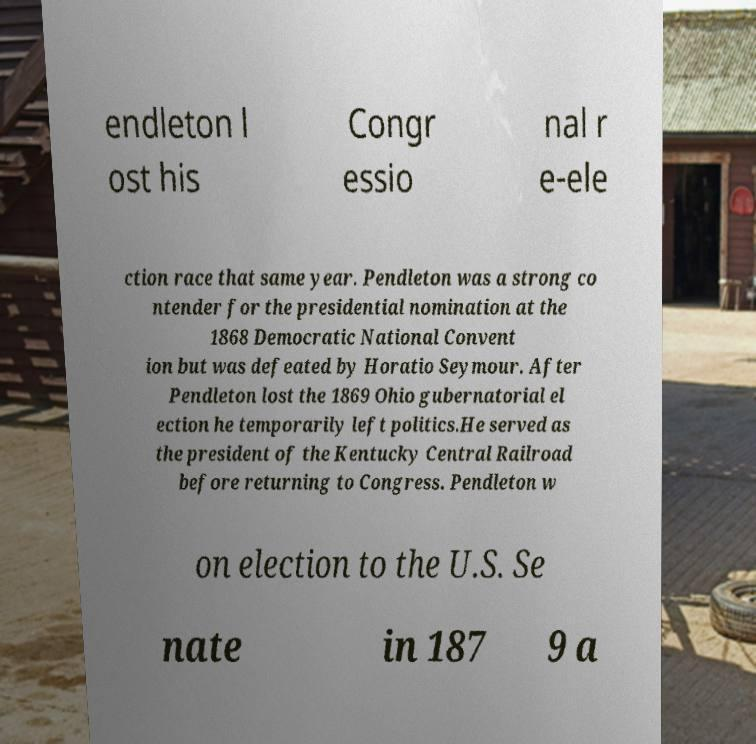What messages or text are displayed in this image? I need them in a readable, typed format. endleton l ost his Congr essio nal r e-ele ction race that same year. Pendleton was a strong co ntender for the presidential nomination at the 1868 Democratic National Convent ion but was defeated by Horatio Seymour. After Pendleton lost the 1869 Ohio gubernatorial el ection he temporarily left politics.He served as the president of the Kentucky Central Railroad before returning to Congress. Pendleton w on election to the U.S. Se nate in 187 9 a 